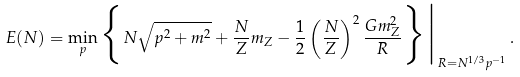Convert formula to latex. <formula><loc_0><loc_0><loc_500><loc_500>E ( N ) = \min _ { p } \Big \{ N \sqrt { p ^ { 2 } + m ^ { 2 } } + \frac { N } { Z } m _ { Z } - \frac { 1 } { 2 } \left ( \frac { N } { Z } \right ) ^ { 2 } \frac { G m _ { Z } ^ { 2 } } { R } \Big \} \Big | _ { R = N ^ { 1 / 3 } p ^ { - 1 } } \, .</formula> 